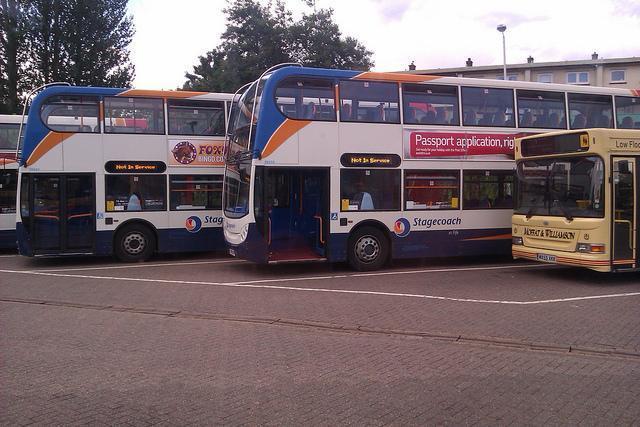How many buses are parked?
Give a very brief answer. 4. How many buses can you see?
Give a very brief answer. 4. 